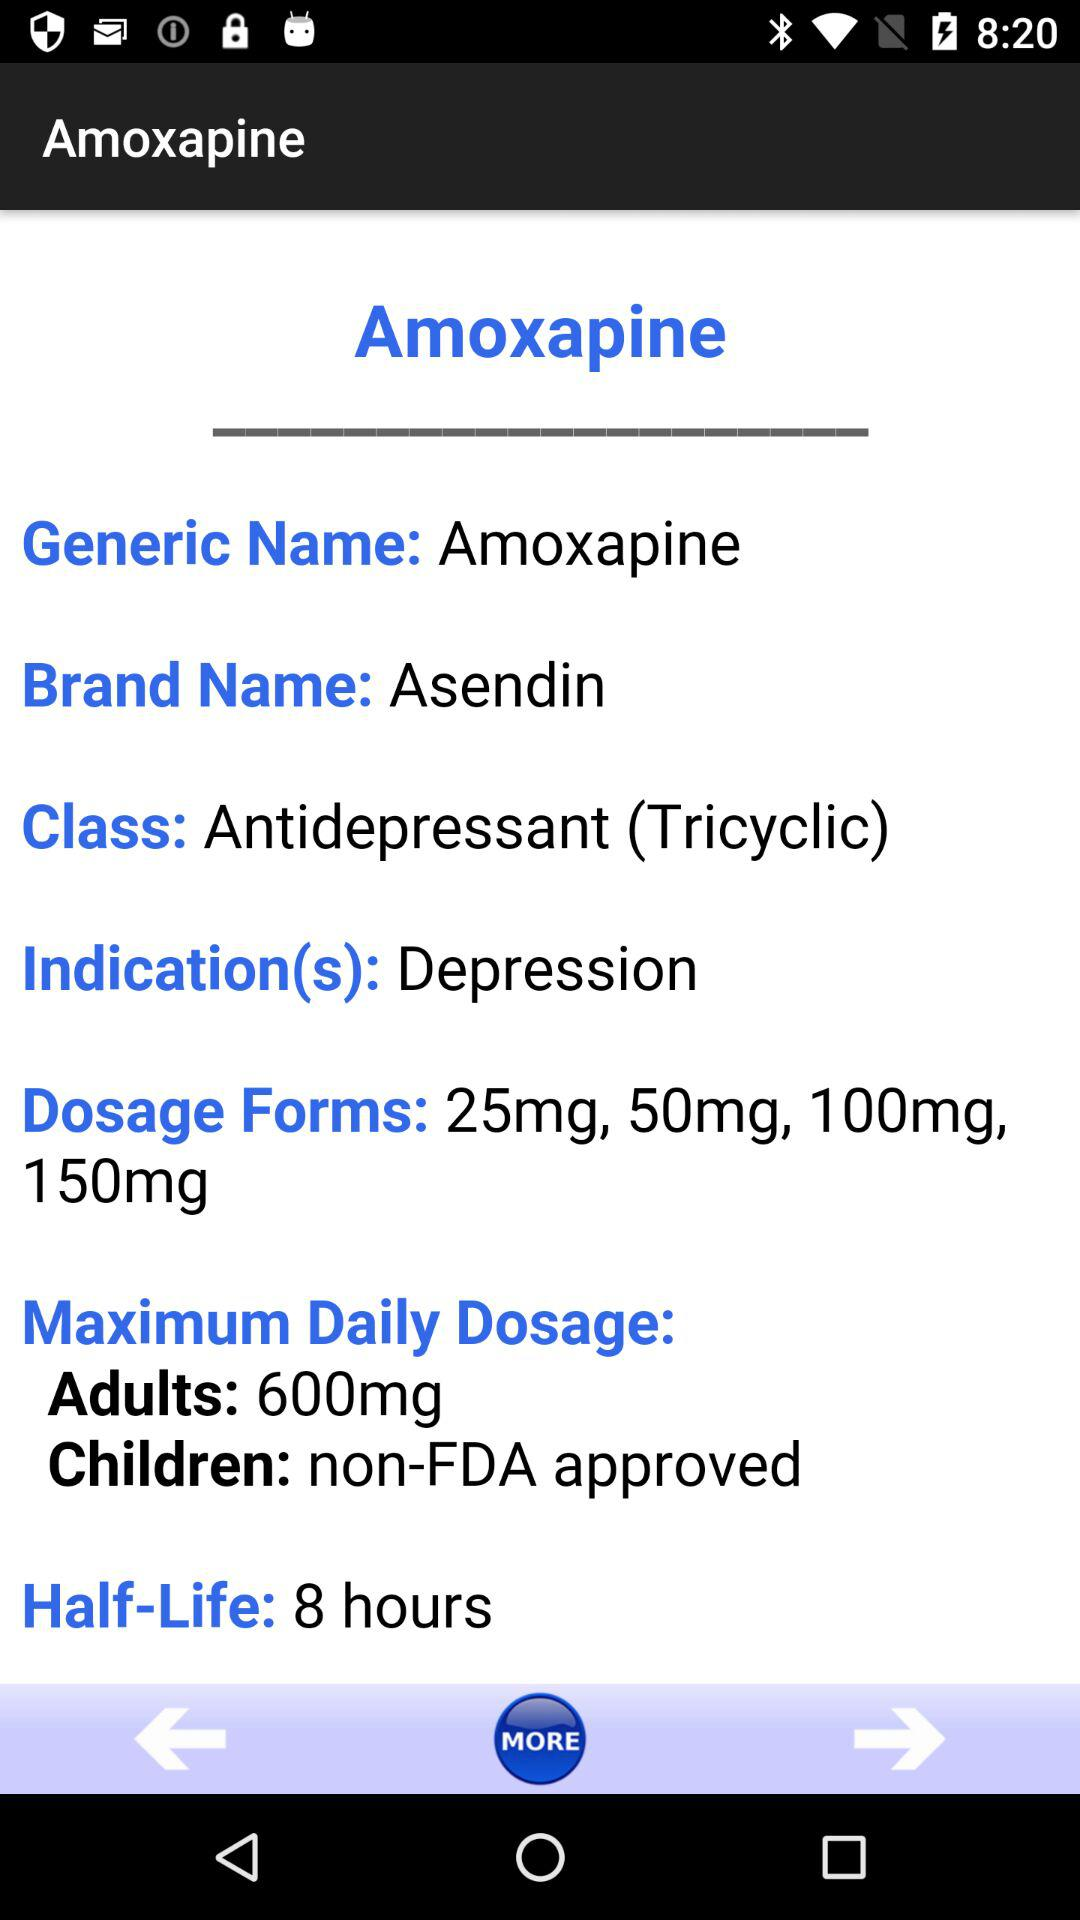What is the class? The class is "Antidepressant (Tricyclic)". 